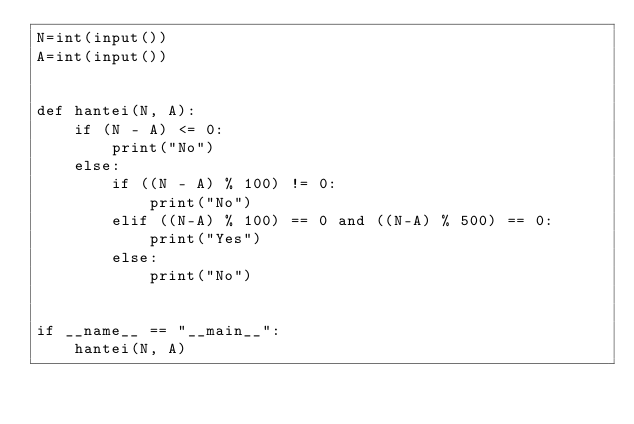Convert code to text. <code><loc_0><loc_0><loc_500><loc_500><_Python_>N=int(input())
A=int(input())


def hantei(N, A):
    if (N - A) <= 0:
        print("No")
    else:
        if ((N - A) % 100) != 0:
            print("No")
        elif ((N-A) % 100) == 0 and ((N-A) % 500) == 0:
            print("Yes")
        else:
            print("No")


if __name__ == "__main__":
    hantei(N, A)</code> 